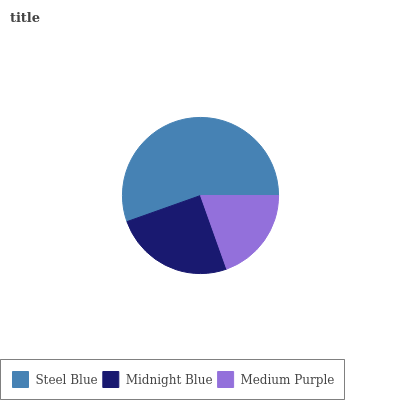Is Medium Purple the minimum?
Answer yes or no. Yes. Is Steel Blue the maximum?
Answer yes or no. Yes. Is Midnight Blue the minimum?
Answer yes or no. No. Is Midnight Blue the maximum?
Answer yes or no. No. Is Steel Blue greater than Midnight Blue?
Answer yes or no. Yes. Is Midnight Blue less than Steel Blue?
Answer yes or no. Yes. Is Midnight Blue greater than Steel Blue?
Answer yes or no. No. Is Steel Blue less than Midnight Blue?
Answer yes or no. No. Is Midnight Blue the high median?
Answer yes or no. Yes. Is Midnight Blue the low median?
Answer yes or no. Yes. Is Medium Purple the high median?
Answer yes or no. No. Is Medium Purple the low median?
Answer yes or no. No. 